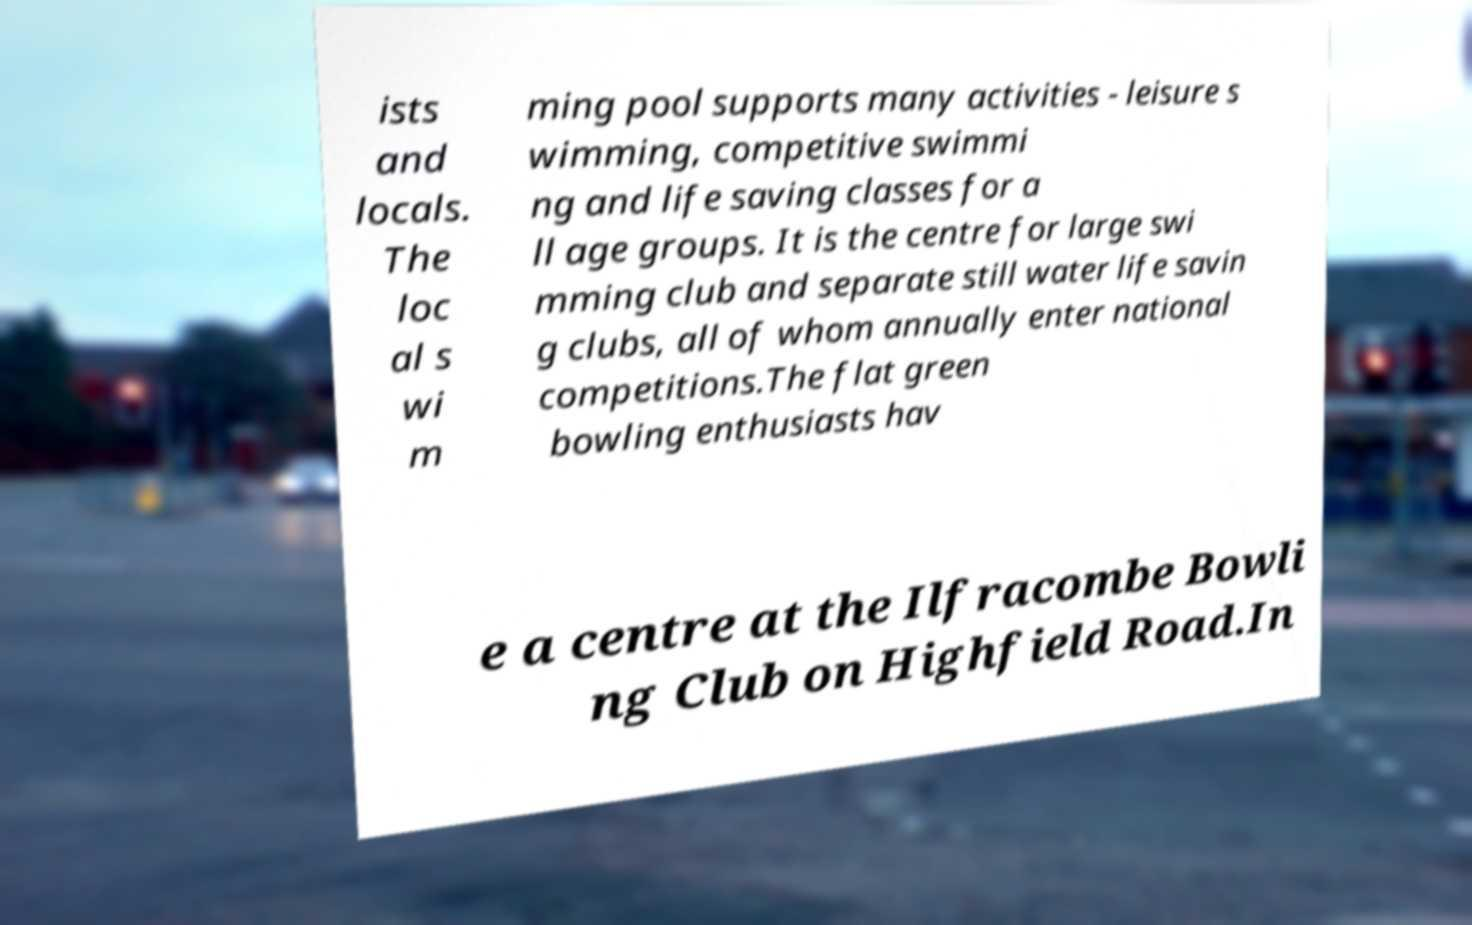Can you accurately transcribe the text from the provided image for me? ists and locals. The loc al s wi m ming pool supports many activities - leisure s wimming, competitive swimmi ng and life saving classes for a ll age groups. It is the centre for large swi mming club and separate still water life savin g clubs, all of whom annually enter national competitions.The flat green bowling enthusiasts hav e a centre at the Ilfracombe Bowli ng Club on Highfield Road.In 